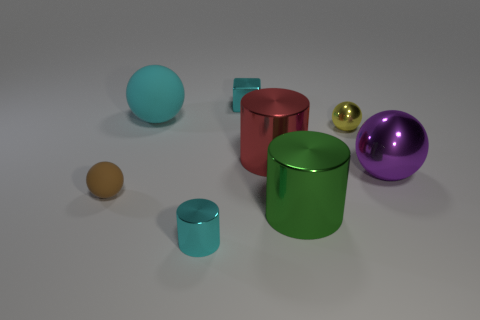Are there any repeated shapes or colors among the objects? Yes, indeed. There are repeated shapes – spheres and cylinders – albeit varying in size and color. However, while the colors are varied, there doesn't appear to be an exact repetition of the same color and size combination on any two objects. 